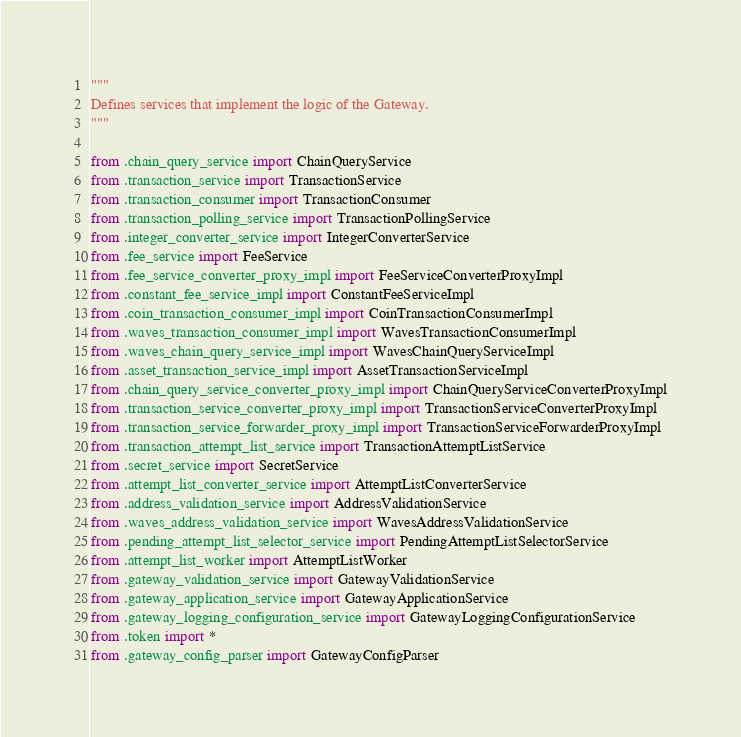<code> <loc_0><loc_0><loc_500><loc_500><_Python_>"""
Defines services that implement the logic of the Gateway.
"""

from .chain_query_service import ChainQueryService
from .transaction_service import TransactionService
from .transaction_consumer import TransactionConsumer
from .transaction_polling_service import TransactionPollingService
from .integer_converter_service import IntegerConverterService
from .fee_service import FeeService
from .fee_service_converter_proxy_impl import FeeServiceConverterProxyImpl
from .constant_fee_service_impl import ConstantFeeServiceImpl
from .coin_transaction_consumer_impl import CoinTransactionConsumerImpl
from .waves_transaction_consumer_impl import WavesTransactionConsumerImpl
from .waves_chain_query_service_impl import WavesChainQueryServiceImpl
from .asset_transaction_service_impl import AssetTransactionServiceImpl
from .chain_query_service_converter_proxy_impl import ChainQueryServiceConverterProxyImpl
from .transaction_service_converter_proxy_impl import TransactionServiceConverterProxyImpl
from .transaction_service_forwarder_proxy_impl import TransactionServiceForwarderProxyImpl
from .transaction_attempt_list_service import TransactionAttemptListService
from .secret_service import SecretService
from .attempt_list_converter_service import AttemptListConverterService
from .address_validation_service import AddressValidationService
from .waves_address_validation_service import WavesAddressValidationService
from .pending_attempt_list_selector_service import PendingAttemptListSelectorService
from .attempt_list_worker import AttemptListWorker
from .gateway_validation_service import GatewayValidationService
from .gateway_application_service import GatewayApplicationService
from .gateway_logging_configuration_service import GatewayLoggingConfigurationService
from .token import *
from .gateway_config_parser import GatewayConfigParser
</code> 